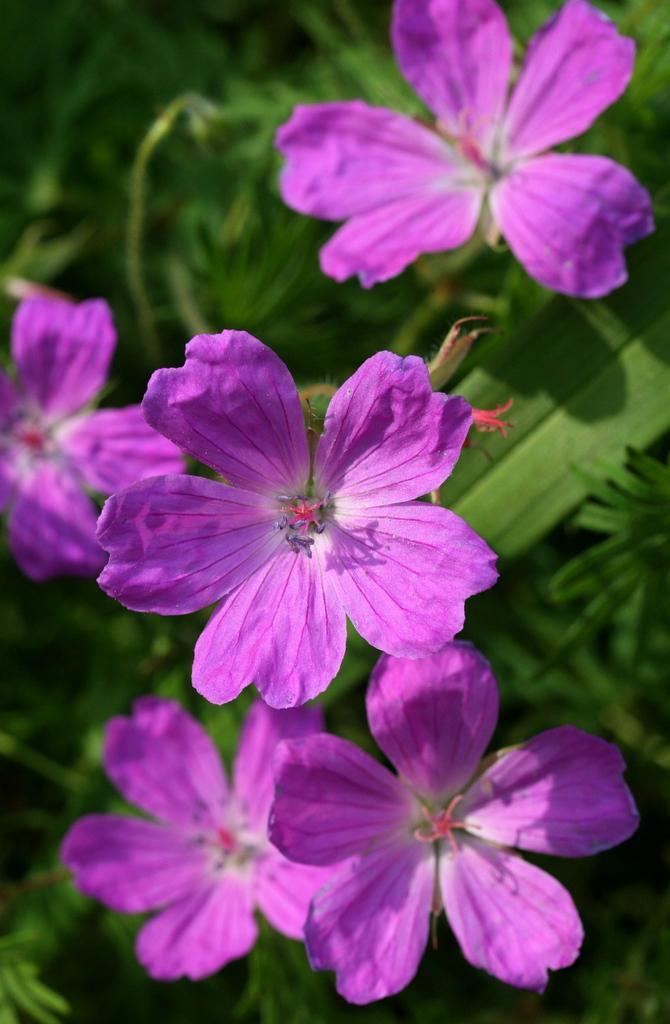Please provide a concise description of this image. It is a zoomed in picture of purple color flowers of the plant. 